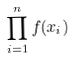<formula> <loc_0><loc_0><loc_500><loc_500>\prod _ { i = 1 } ^ { n } f ( x _ { i } )</formula> 